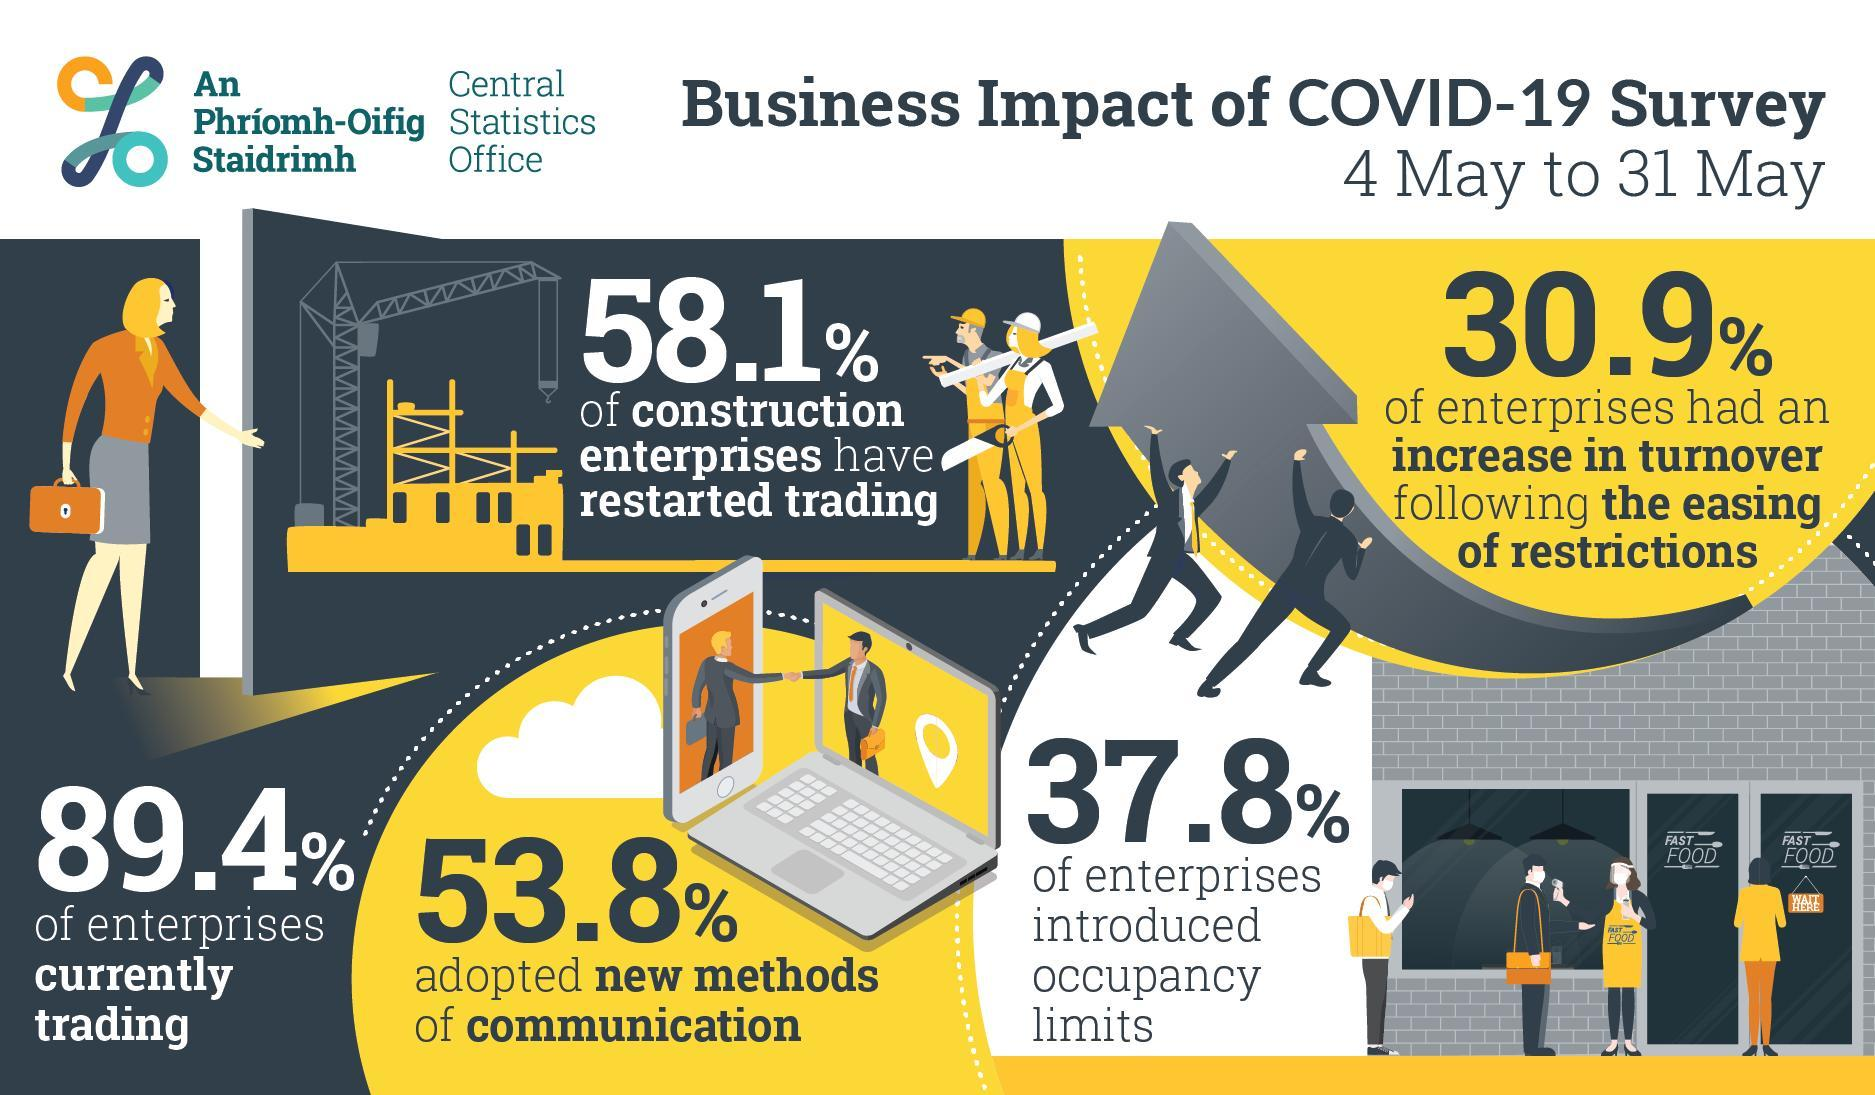What is written on the apron worn by the lady
Answer the question with a short phrase. Fast Food What is written on the sign board hanging on the door Wait here What % adopted new methods of communication 53.8 How many enterprises introduced occupancy limits 37.8 WHat is the % of construction enterprises that have restarted trading 58.1 